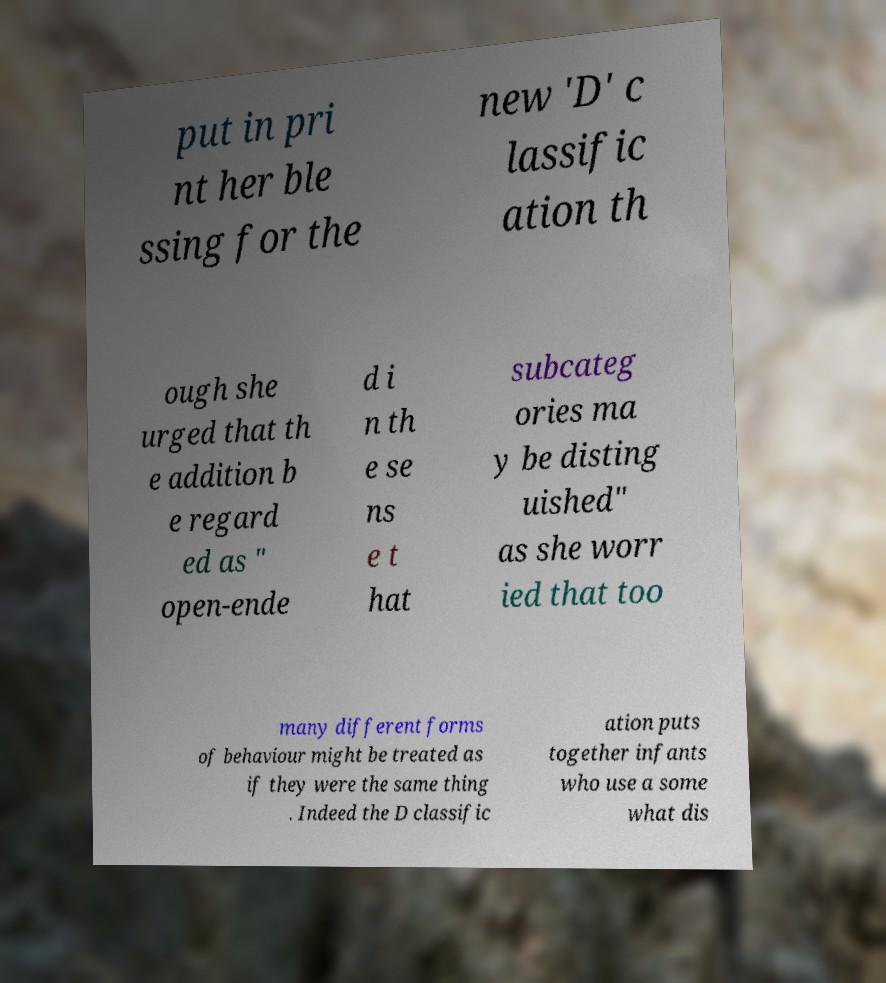I need the written content from this picture converted into text. Can you do that? put in pri nt her ble ssing for the new 'D' c lassific ation th ough she urged that th e addition b e regard ed as " open-ende d i n th e se ns e t hat subcateg ories ma y be disting uished" as she worr ied that too many different forms of behaviour might be treated as if they were the same thing . Indeed the D classific ation puts together infants who use a some what dis 